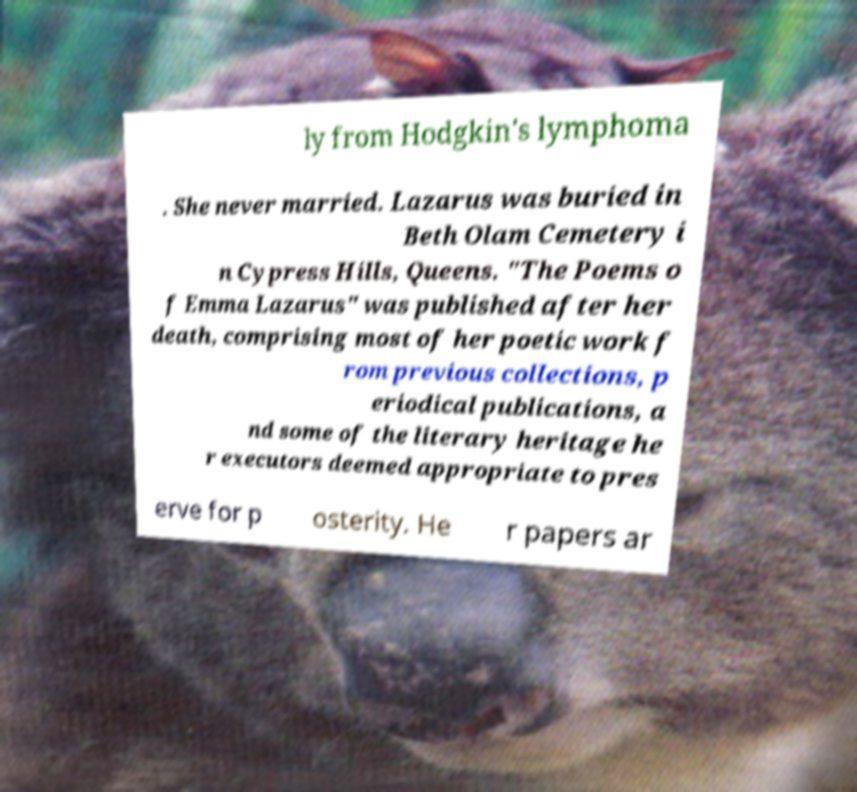Please identify and transcribe the text found in this image. ly from Hodgkin's lymphoma . She never married. Lazarus was buried in Beth Olam Cemetery i n Cypress Hills, Queens. "The Poems o f Emma Lazarus" was published after her death, comprising most of her poetic work f rom previous collections, p eriodical publications, a nd some of the literary heritage he r executors deemed appropriate to pres erve for p osterity. He r papers ar 